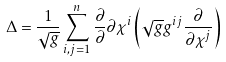<formula> <loc_0><loc_0><loc_500><loc_500>\Delta = \frac { 1 } { \sqrt { g } } \sum _ { i , j = 1 } ^ { n } \frac { \partial } { \partial } { \partial \chi ^ { i } } \left ( \sqrt { g } g ^ { i j } \frac { \partial } { \partial \chi ^ { j } } \right )</formula> 